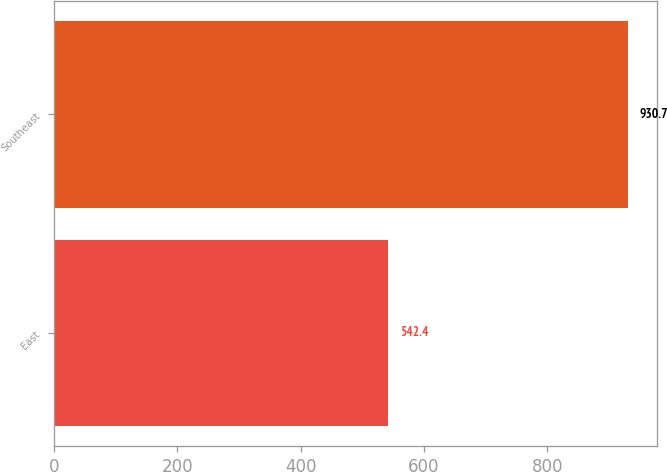<chart> <loc_0><loc_0><loc_500><loc_500><bar_chart><fcel>East<fcel>Southeast<nl><fcel>542.4<fcel>930.7<nl></chart> 